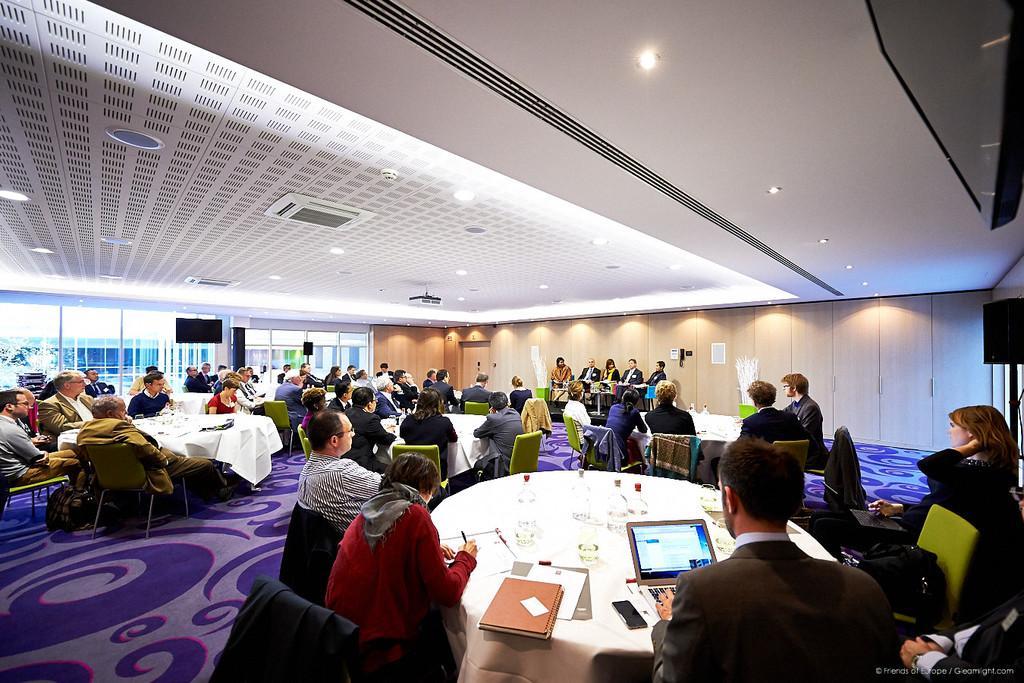Could you give a brief overview of what you see in this image? In this image there are group of persons sitting on the table and chairs. At the middle of the image there are four group of persons sitting on the table and at the left side of the image there is a glass window and at the right side of the image there is a sound box. 